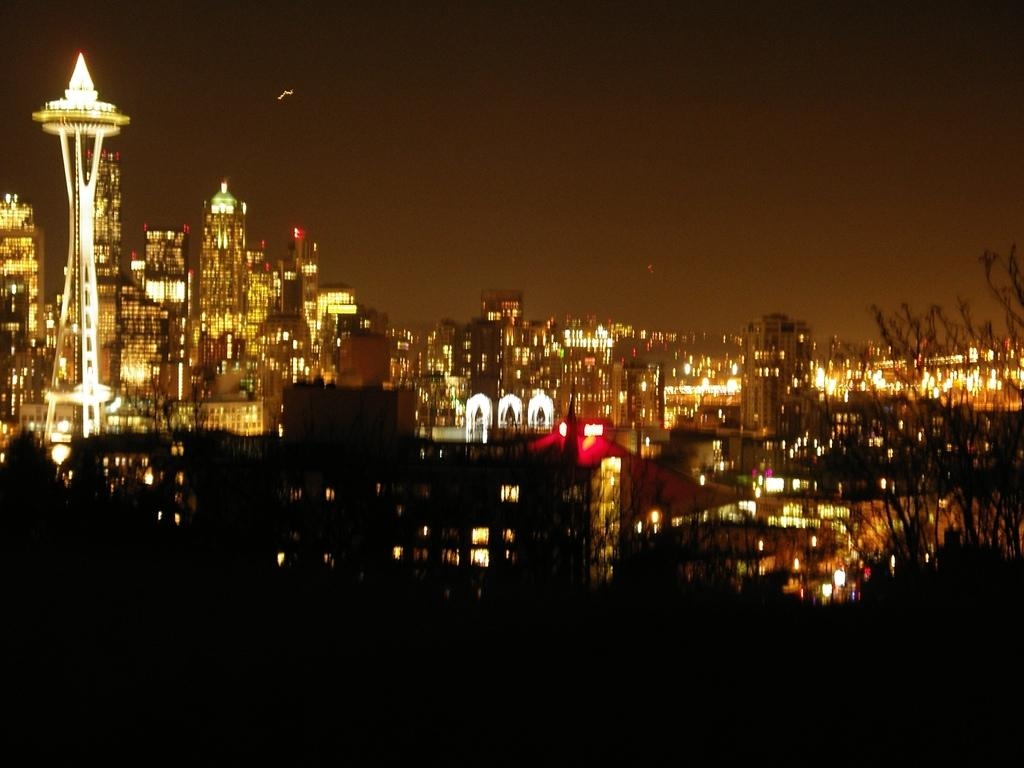What time of day was the image taken? The image was taken at night. What can be seen in the foreground of the image? The foreground of the image is dark. What is the main focus of the image? There are buildings and lights in the center of the image. What is visible at the top of the image? The sky is visible at the top of the image. What type of writing can be seen on the buildings in the image? There is no writing visible on the buildings in the image. Are the people in the image sleeping? There are no people visible in the image, so it cannot be determined if they are sleeping or not. 